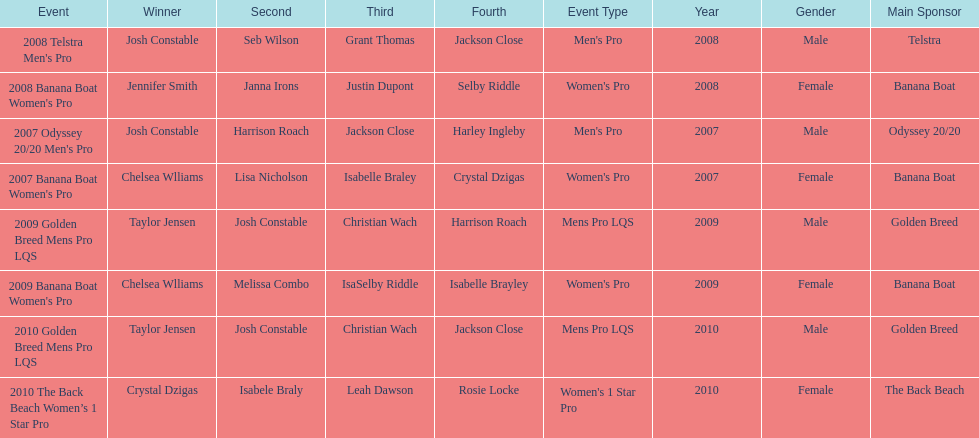How many times was josh constable second? 2. 